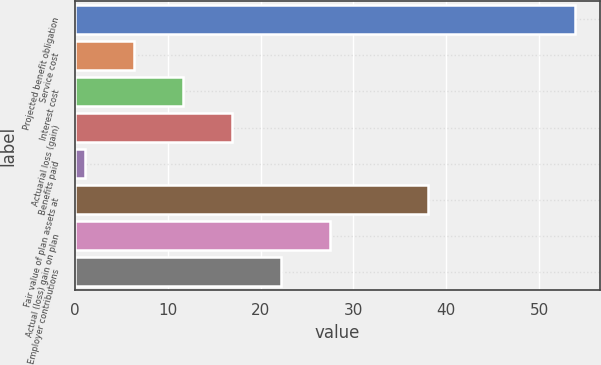Convert chart. <chart><loc_0><loc_0><loc_500><loc_500><bar_chart><fcel>Projected benefit obligation<fcel>Service cost<fcel>Interest cost<fcel>Actuarial loss (gain)<fcel>Benefits paid<fcel>Fair value of plan assets at<fcel>Actual (loss) gain on plan<fcel>Employer contributions<nl><fcel>53.9<fcel>6.38<fcel>11.66<fcel>16.94<fcel>1.1<fcel>38.06<fcel>27.5<fcel>22.22<nl></chart> 